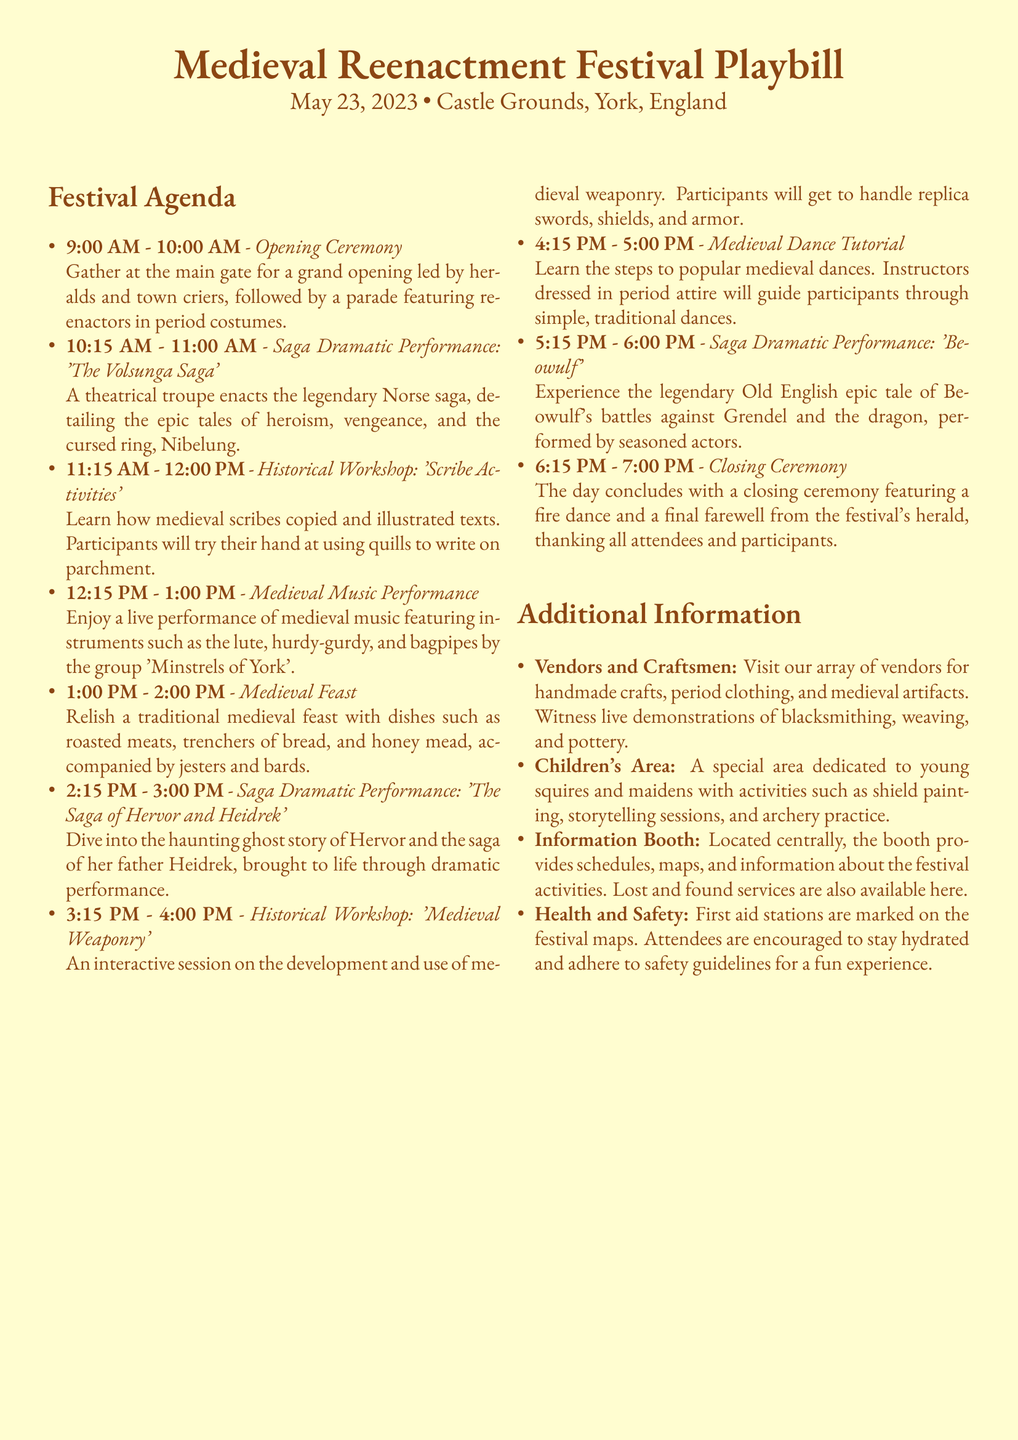What time does the festival start? The festival starts with the Opening Ceremony at 9:00 AM.
Answer: 9:00 AM How many saga performances are there? There are three saga dramatic performances listed in the agenda.
Answer: three What is the setting of the festival? The festival takes place in the Castle Grounds, York, England.
Answer: Castle Grounds, York, England What type of food is provided during the Medieval Feast? The Medieval Feast includes dishes such as roasted meats and honey mead.
Answer: roasted meats, honey mead What activity is scheduled directly after the Medieval Feast? The next scheduled activity after the Medieval Feast is a saga performance.
Answer: Saga Dramatic Performance: 'The Saga of Hervor and Heidrek' Which performers are highlighted in the music section? The medieval music performance features the group 'Minstrels of York'.
Answer: Minstrels of York What can children do in the Children's Area? Activities include shield painting and storytelling sessions for children.
Answer: shield painting, storytelling sessions 